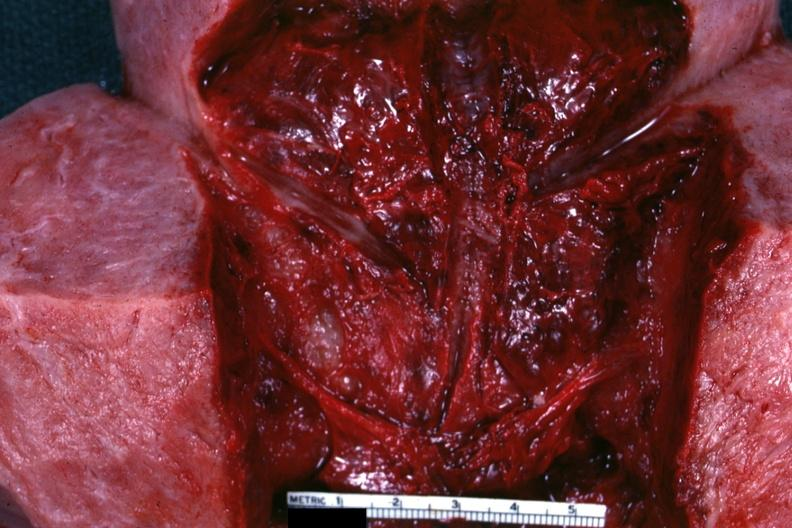what is present?
Answer the question using a single word or phrase. Uterus 